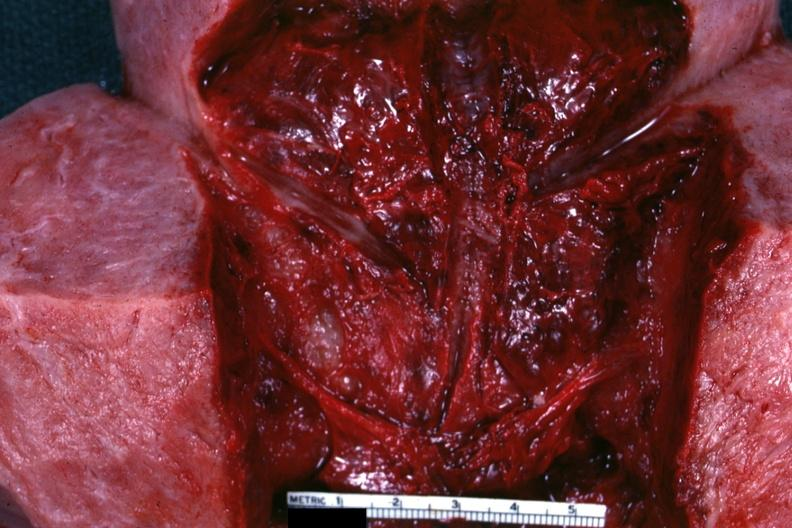what is present?
Answer the question using a single word or phrase. Uterus 